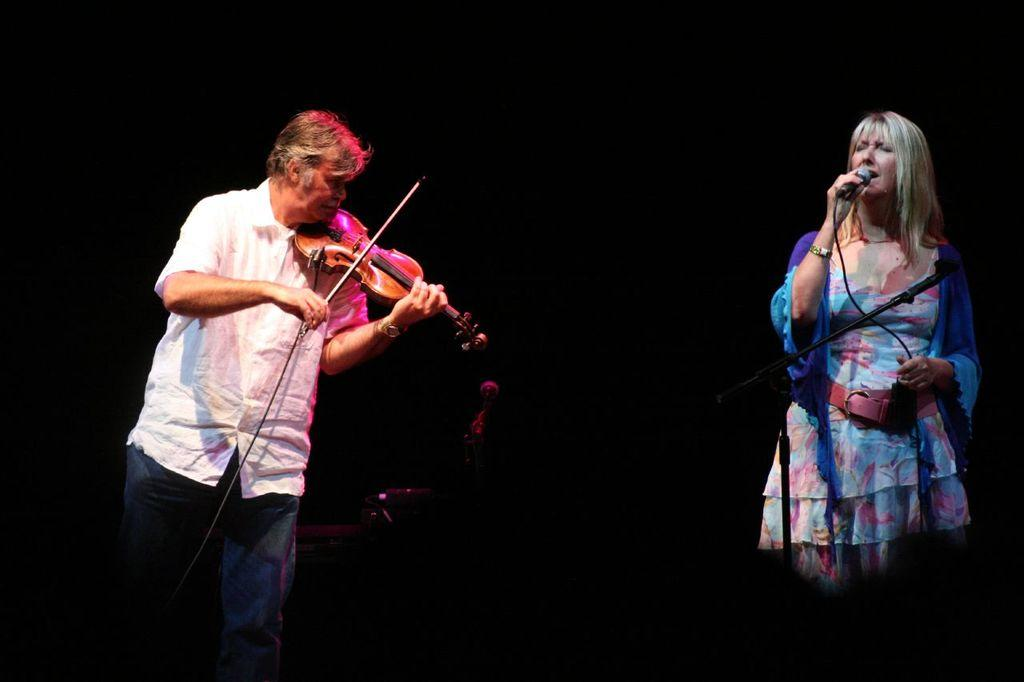What is the man doing in the image? The man is playing a violin with a stick in the image. What is the woman doing in the image? The woman is singing in front of a mic in the image. What is used to hold the mic in place? There is a mic holder present in the image. What direction is the man stretching his grip while playing the violin? There is no indication of the man stretching his grip or any specific direction in the image. 